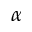Convert formula to latex. <formula><loc_0><loc_0><loc_500><loc_500>\alpha</formula> 